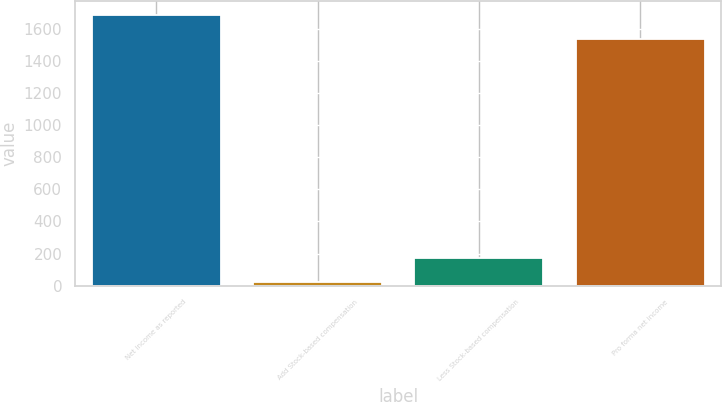Convert chart. <chart><loc_0><loc_0><loc_500><loc_500><bar_chart><fcel>Net income as reported<fcel>Add Stock-based compensation<fcel>Less Stock-based compensation<fcel>Pro forma net income<nl><fcel>1686.66<fcel>20.7<fcel>175.46<fcel>1531.9<nl></chart> 